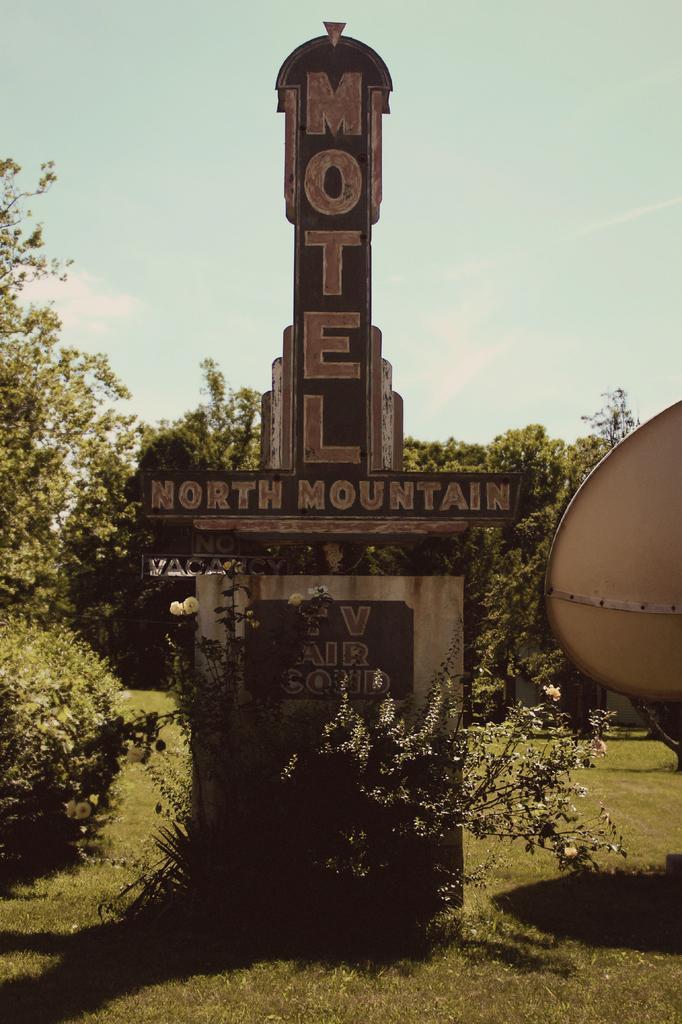How would you summarize this image in a sentence or two? In this image we can see a structure with some text and we can also see trees, grass and sky. 